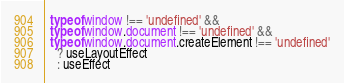Convert code to text. <code><loc_0><loc_0><loc_500><loc_500><_JavaScript_>  typeof window !== 'undefined' &&
  typeof window.document !== 'undefined' &&
  typeof window.document.createElement !== 'undefined'
    ? useLayoutEffect
    : useEffect</code> 